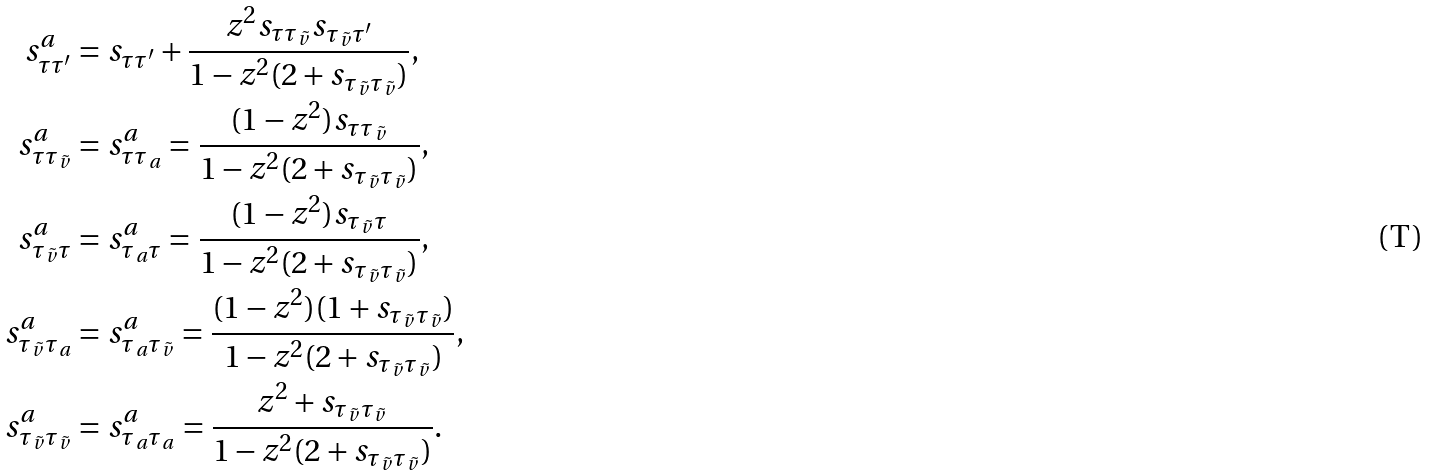Convert formula to latex. <formula><loc_0><loc_0><loc_500><loc_500>s ^ { a } _ { \tau \tau ^ { \prime } } & = s _ { \tau \tau ^ { \prime } } + \frac { z ^ { 2 } s _ { \tau \tau _ { \tilde { v } } } s _ { \tau _ { \tilde { v } } \tau ^ { \prime } } } { 1 - z ^ { 2 } ( 2 + s _ { \tau _ { \tilde { v } } \tau _ { \tilde { v } } } ) } , \\ s ^ { a } _ { \tau \tau _ { \tilde { v } } } & = s ^ { a } _ { \tau \tau _ { a } } = \frac { ( 1 - z ^ { 2 } ) s _ { \tau \tau _ { \tilde { v } } } } { 1 - z ^ { 2 } ( 2 + s _ { \tau _ { \tilde { v } } \tau _ { \tilde { v } } } ) } , \\ s ^ { a } _ { \tau _ { \tilde { v } } \tau } & = s ^ { a } _ { \tau _ { a } \tau } = \frac { ( 1 - z ^ { 2 } ) s _ { \tau _ { \tilde { v } } \tau } } { 1 - z ^ { 2 } ( 2 + s _ { \tau _ { \tilde { v } } \tau _ { \tilde { v } } } ) } , \\ s ^ { a } _ { \tau _ { \tilde { v } } \tau _ { a } } & = s ^ { a } _ { \tau _ { a } \tau _ { \tilde { v } } } = \frac { ( 1 - z ^ { 2 } ) ( 1 + s _ { \tau _ { \tilde { v } } \tau _ { \tilde { v } } } ) } { 1 - z ^ { 2 } ( 2 + s _ { \tau _ { \tilde { v } } \tau _ { \tilde { v } } } ) } , \\ s ^ { a } _ { \tau _ { \tilde { v } } \tau _ { \tilde { v } } } & = s ^ { a } _ { \tau _ { a } \tau _ { a } } = \frac { z ^ { 2 } + s _ { \tau _ { \tilde { v } } \tau _ { \tilde { v } } } } { 1 - z ^ { 2 } ( 2 + s _ { \tau _ { \tilde { v } } \tau _ { \tilde { v } } } ) } .</formula> 